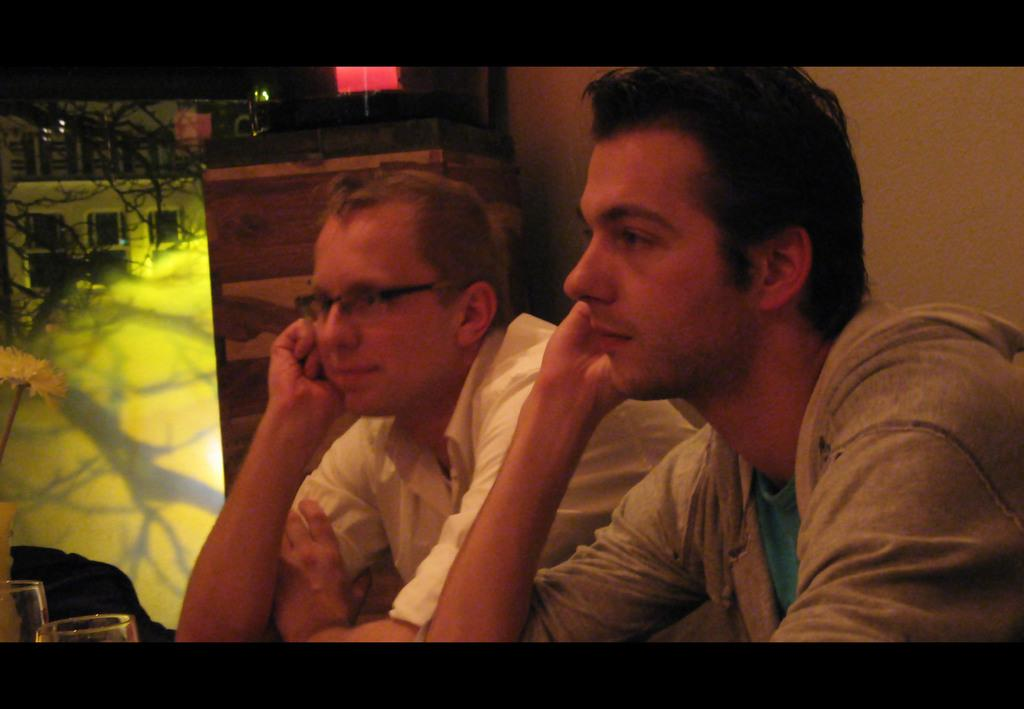How many people are in the image? There are two persons in the image. What are the persons wearing? The persons are wearing clothes. Where can glasses be found in the image? The glasses are in the bottom left of the image. What type of books are the persons holding in the image? There are no books present in the image. How many strands of hair can be seen on the persons' heads in the image? The facts provided do not mention anything about the persons' hair, so we cannot determine the number of strands. 